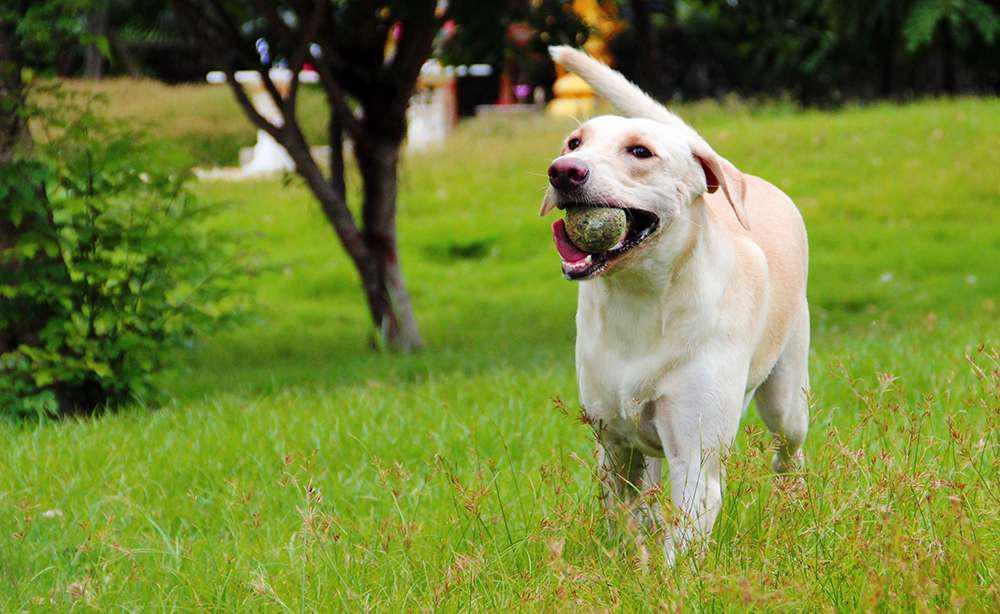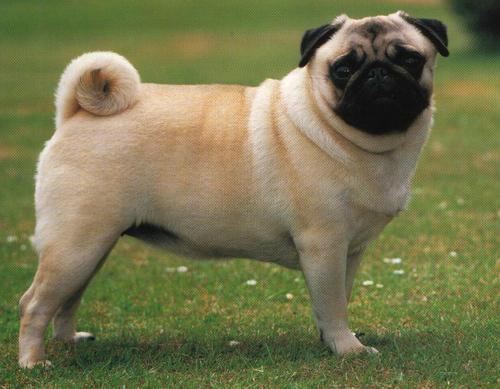The first image is the image on the left, the second image is the image on the right. Considering the images on both sides, is "A large stick-like object is on the grass near a dog in one image." valid? Answer yes or no. No. 